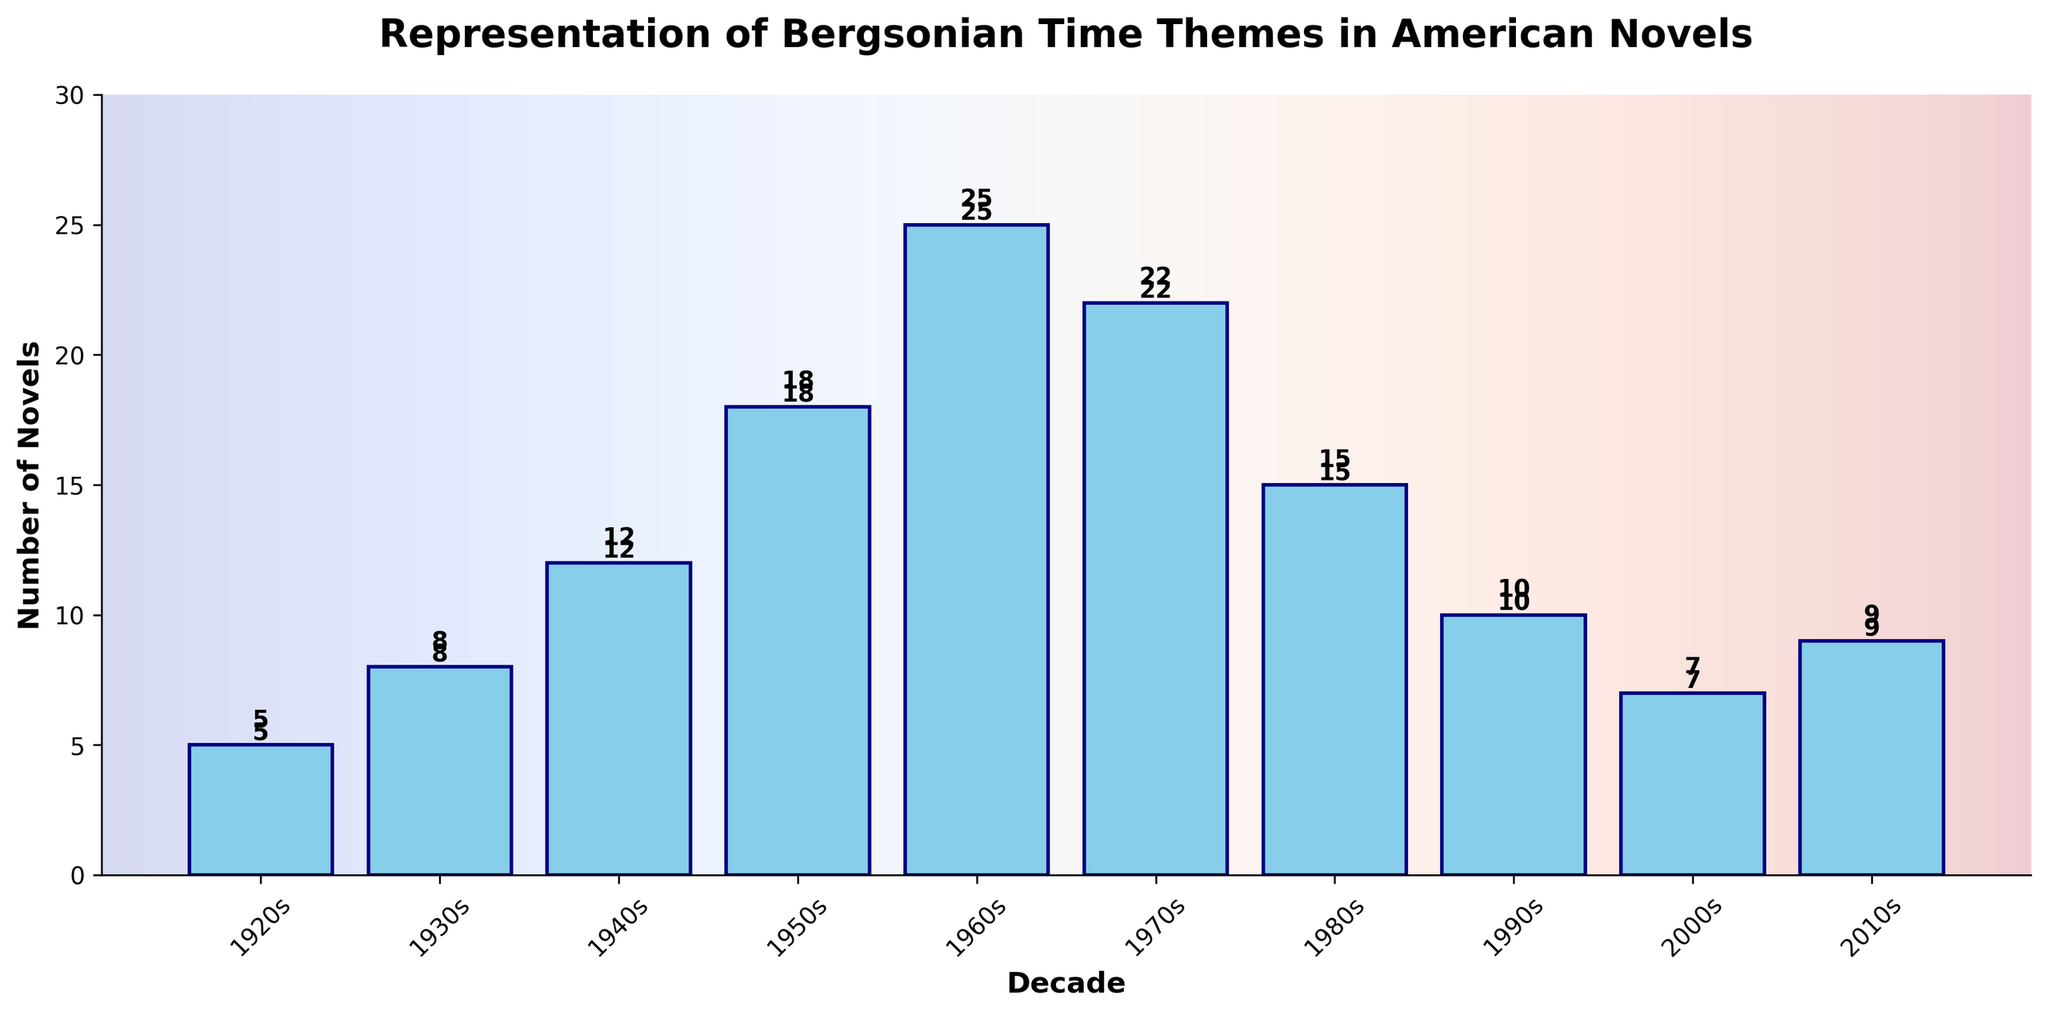What's the average number of novels with Bergsonian time themes per decade? To find the average, sum the number of novels across all decades and then divide by the number of decades. The total is 5 + 8 + 12 + 18 + 25 + 22 + 15 + 10 + 7 + 9 = 131. There are 10 decades, so the average is 131 / 10 = 13.1.
Answer: 13.1 Which decade had the highest number of novels with Bergsonian time themes, and how many novels were there? By examining the heights of the bars, the 1960s decade had the highest bar, indicating the highest number of novels. The number on the bar confirms this with 25 novels.
Answer: 1960s, 25 novels Which decade shows a decrease in the number of novels compared to the previous decade, and how much is the decrease? Comparing consecutive bars, one decrease occurs from the 1960s (25 novels) to the 1970s (22 novels). The decrease is 25 - 22 = 3.
Answer: 1970s, 3 novels What is the total number of novels with Bergsonian time themes from the second half of the century (1950s to 2010s)? Add the number of novels from 1950s, 1960s, 1970s, 1980s, 1990s, 2000s, and 2010s: 18 + 25 + 22 + 15 + 10 + 7 + 9 = 106.
Answer: 106 How many more novels with Bergsonian time themes were there in the 1960s compared to the 1920s? Compare the number of novels in the 1960s (25) to the number in the 1920s (5). The difference is 25 - 5 = 20.
Answer: 20 novels Between which two consecutive decades was there the greatest increase in the number of novels? Look for the largest positive difference between consecutive decades. The largest increase is from the 1950s (18) to the 1960s (25). The increase is 25 - 18 = 7.
Answer: 1950s to 1960s, 7 novels What is the median number of novels with Bergsonian time themes across the decades? To find the median, first arrange the numbers in ascending order: 5, 7, 8, 9, 10, 12, 15, 18, 22, 25. The median is the average of the 5th and 6th values because there are 10 data points. So, median = (10 + 12) / 2 = 11.
Answer: 11 novels Which two decades have the smallest difference in the number of novels, and what is that difference? Examine the differences between consecutive decades: The smallest difference is between 1940s (12) and 1950s (18), with a difference of 18 - 12 = 6.
Answer: 1940s and 1950s, 6 novels What is the total number of novels with Bergsonian time themes in the first half of the century (1900s to 1940s)? Add the number of novels from 1920s, 1930s, and 1940s: 5 + 8 + 12 = 25.
Answer: 25 